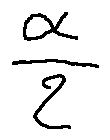<formula> <loc_0><loc_0><loc_500><loc_500>\frac { \alpha } { 2 }</formula> 